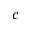<formula> <loc_0><loc_0><loc_500><loc_500>c</formula> 